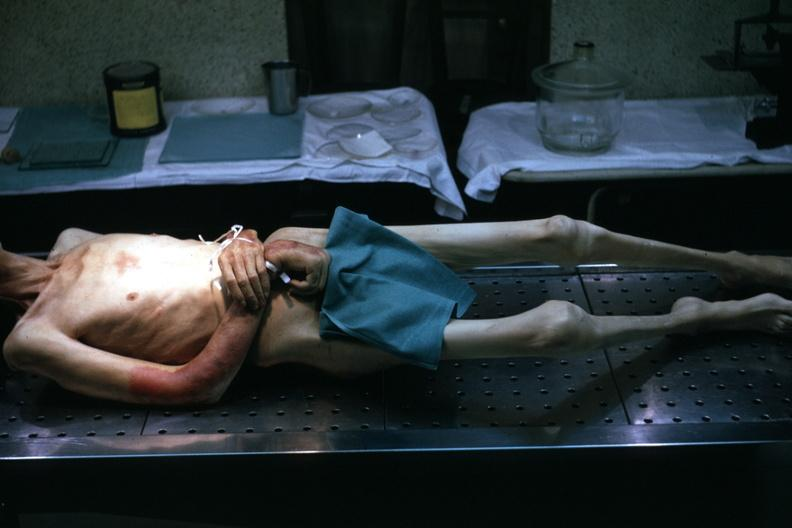does leiomyosarcoma show good example tastefully shown with face out of picture and genitalia covered muscle atrophy is striking?
Answer the question using a single word or phrase. No 